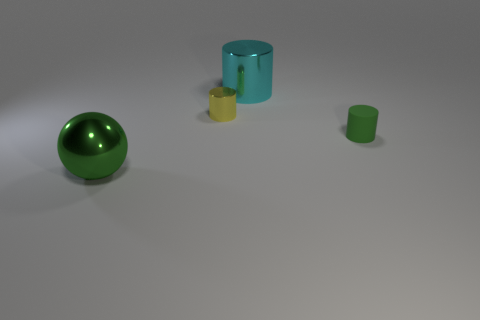Are there any other things that have the same material as the green cylinder?
Ensure brevity in your answer.  No. There is another large object that is the same color as the matte object; what is it made of?
Your answer should be very brief. Metal. What number of things are either big purple matte objects or cylinders?
Make the answer very short. 3. Is there a small matte object that has the same color as the metal sphere?
Ensure brevity in your answer.  Yes. How many big metallic things are to the left of the big shiny object behind the big green metallic sphere?
Keep it short and to the point. 1. Are there more gray metal cylinders than big cylinders?
Keep it short and to the point. No. Is the big ball made of the same material as the small green thing?
Offer a terse response. No. Are there the same number of small metal things to the right of the large cyan metal cylinder and large cyan rubber cylinders?
Your answer should be compact. Yes. How many cyan things have the same material as the big green sphere?
Keep it short and to the point. 1. Is the number of green rubber cylinders less than the number of objects?
Offer a terse response. Yes. 